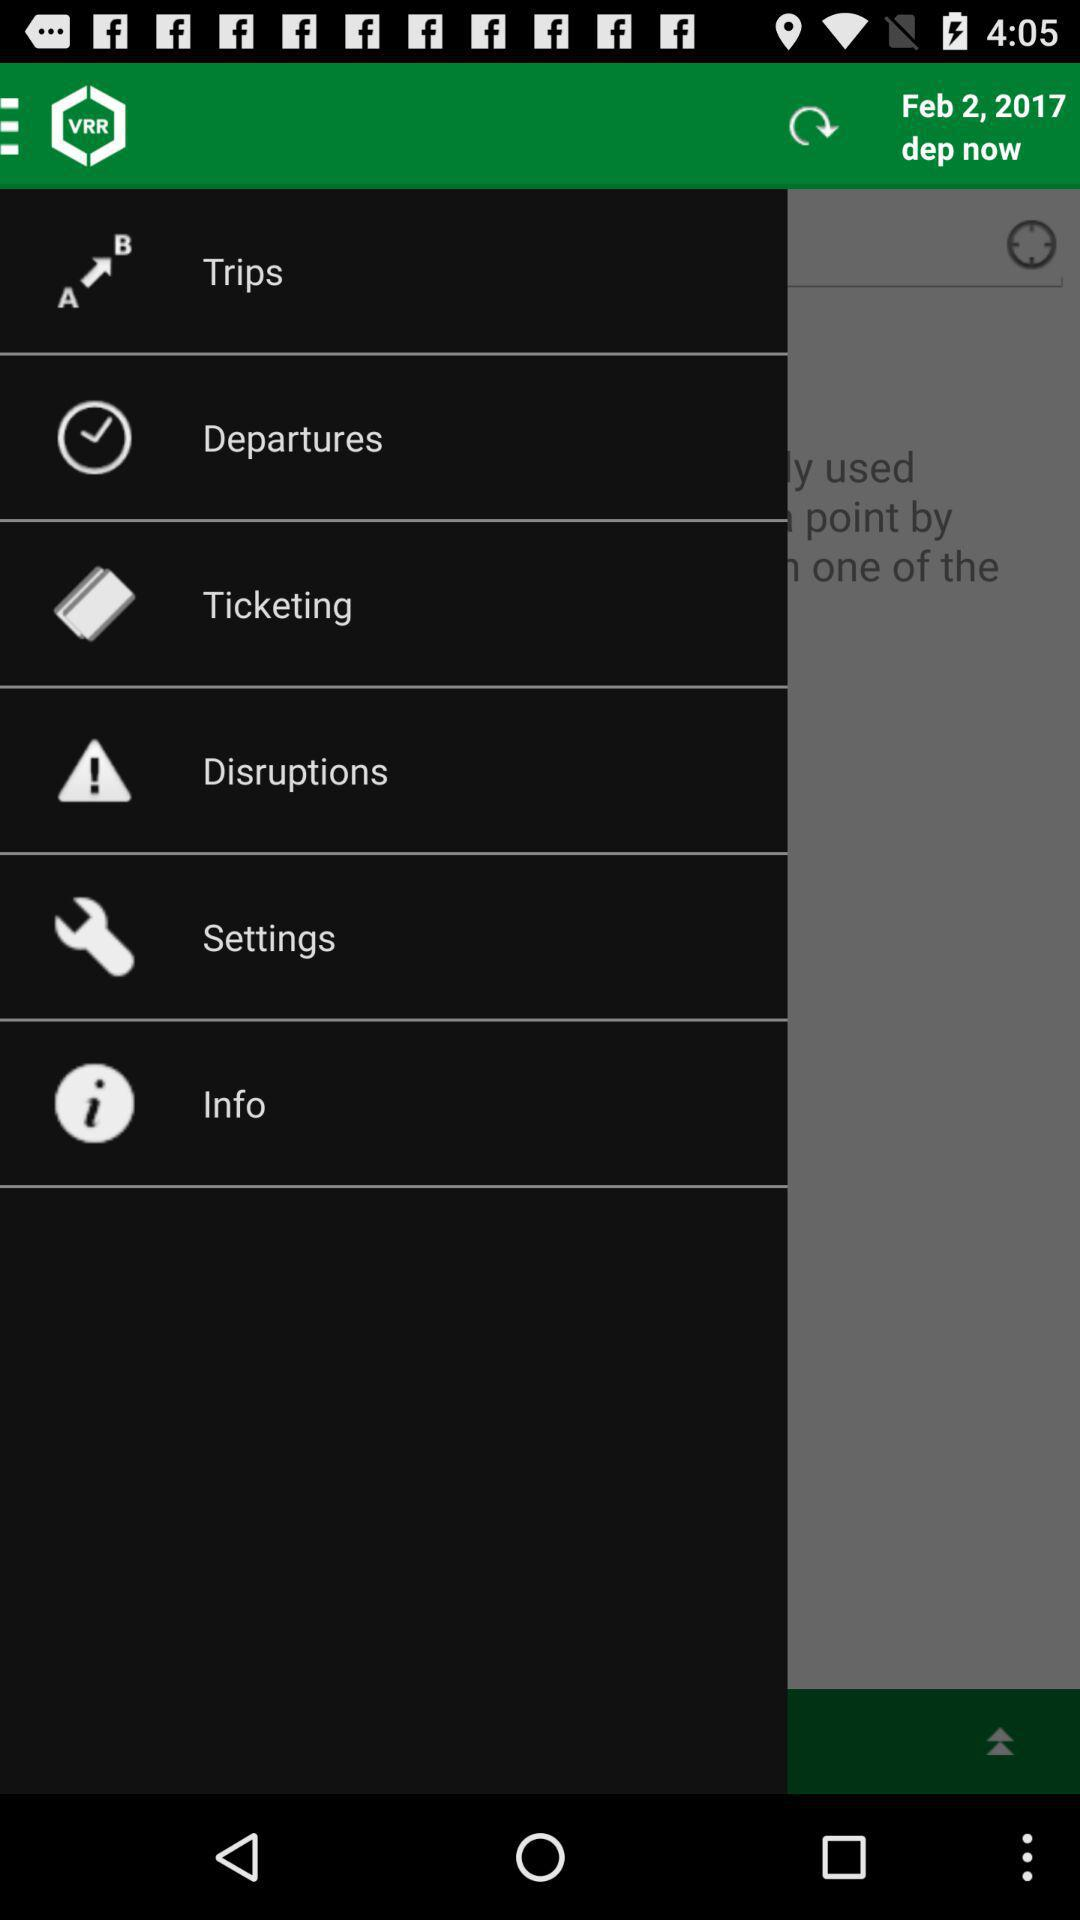What is the application name? The application name is "VRR App – Bus, Bahn, Bike, P+R". 